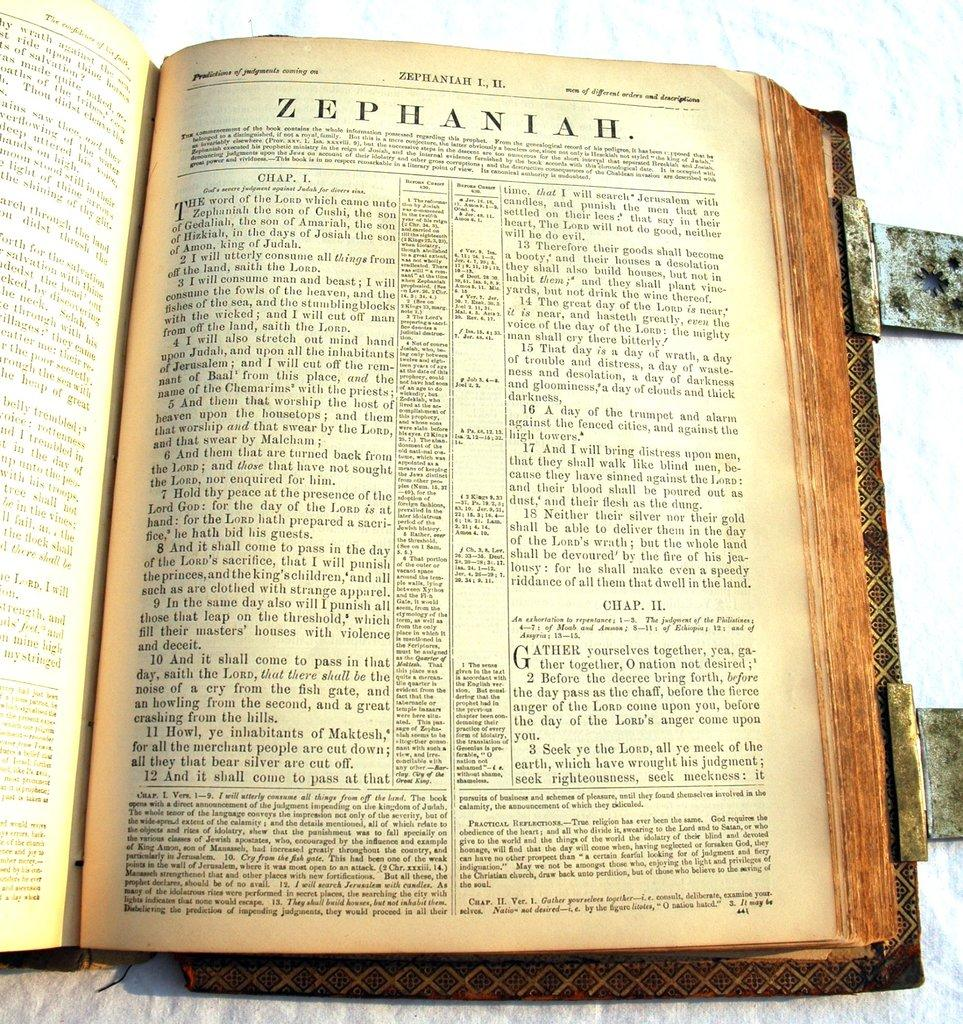<image>
Provide a brief description of the given image. An old book is open to a chapter called Zephaniah. 